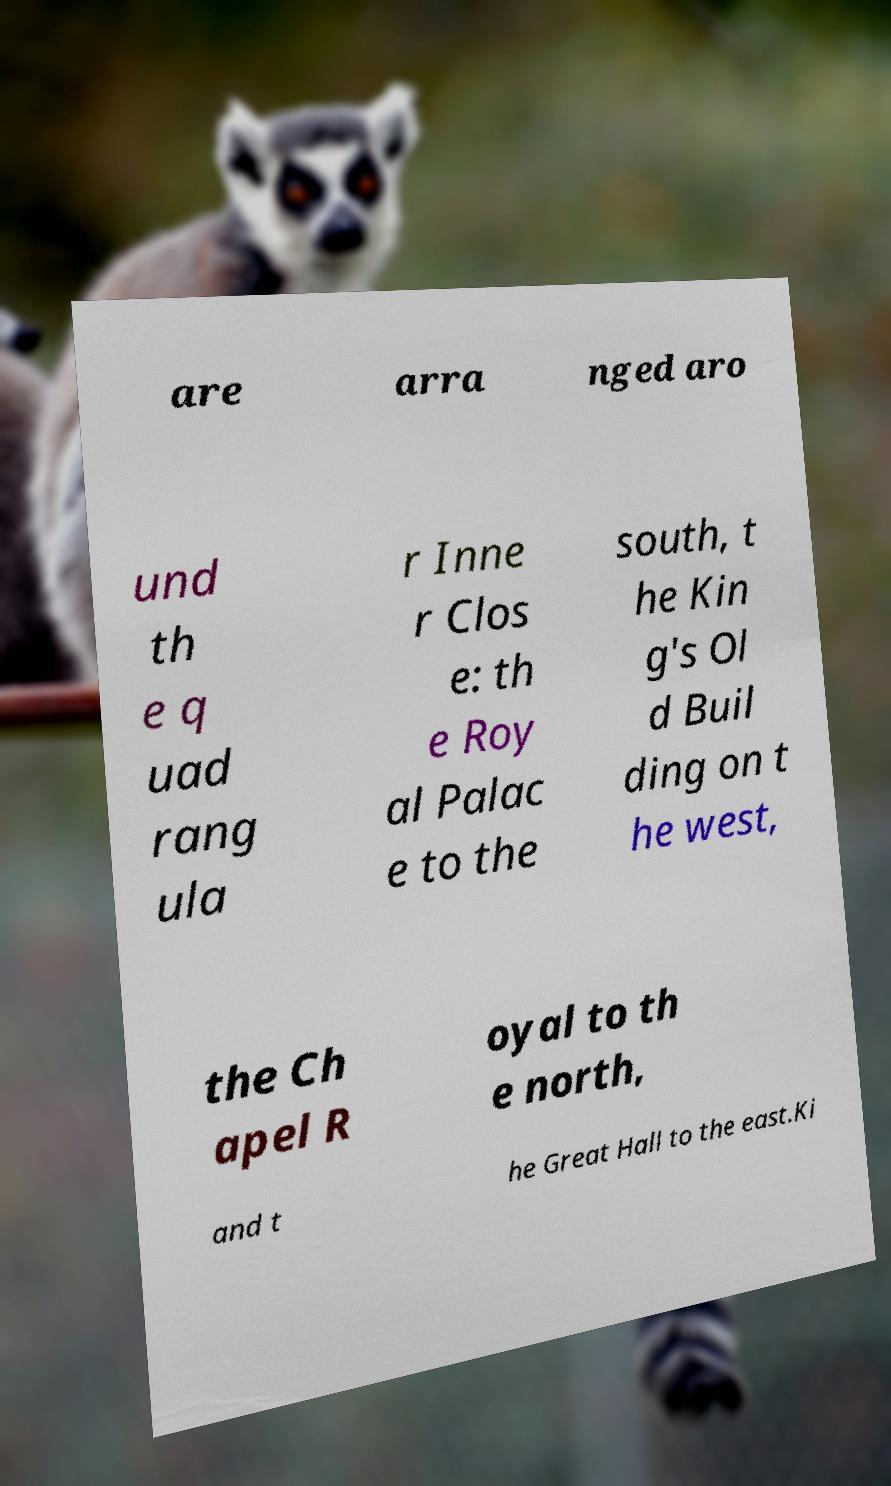Could you extract and type out the text from this image? are arra nged aro und th e q uad rang ula r Inne r Clos e: th e Roy al Palac e to the south, t he Kin g's Ol d Buil ding on t he west, the Ch apel R oyal to th e north, and t he Great Hall to the east.Ki 